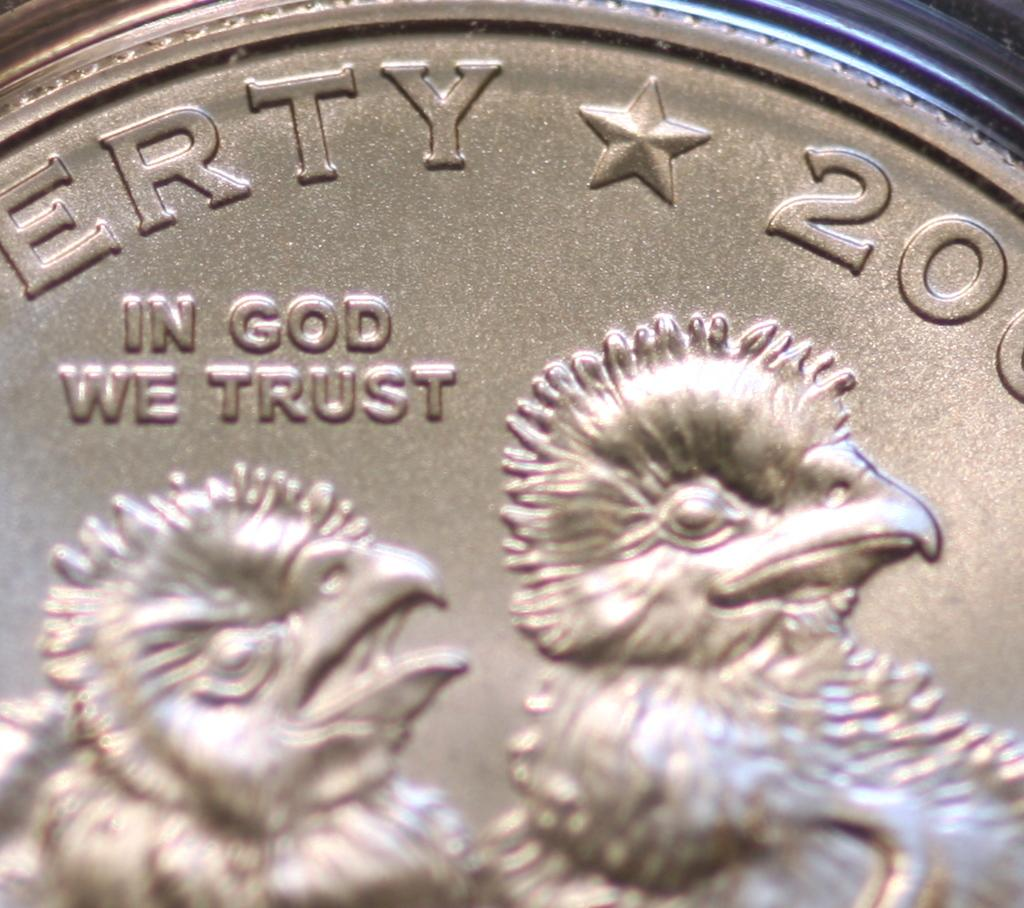<image>
Render a clear and concise summary of the photo. A coin with chicks on it that says In God We Trust. 